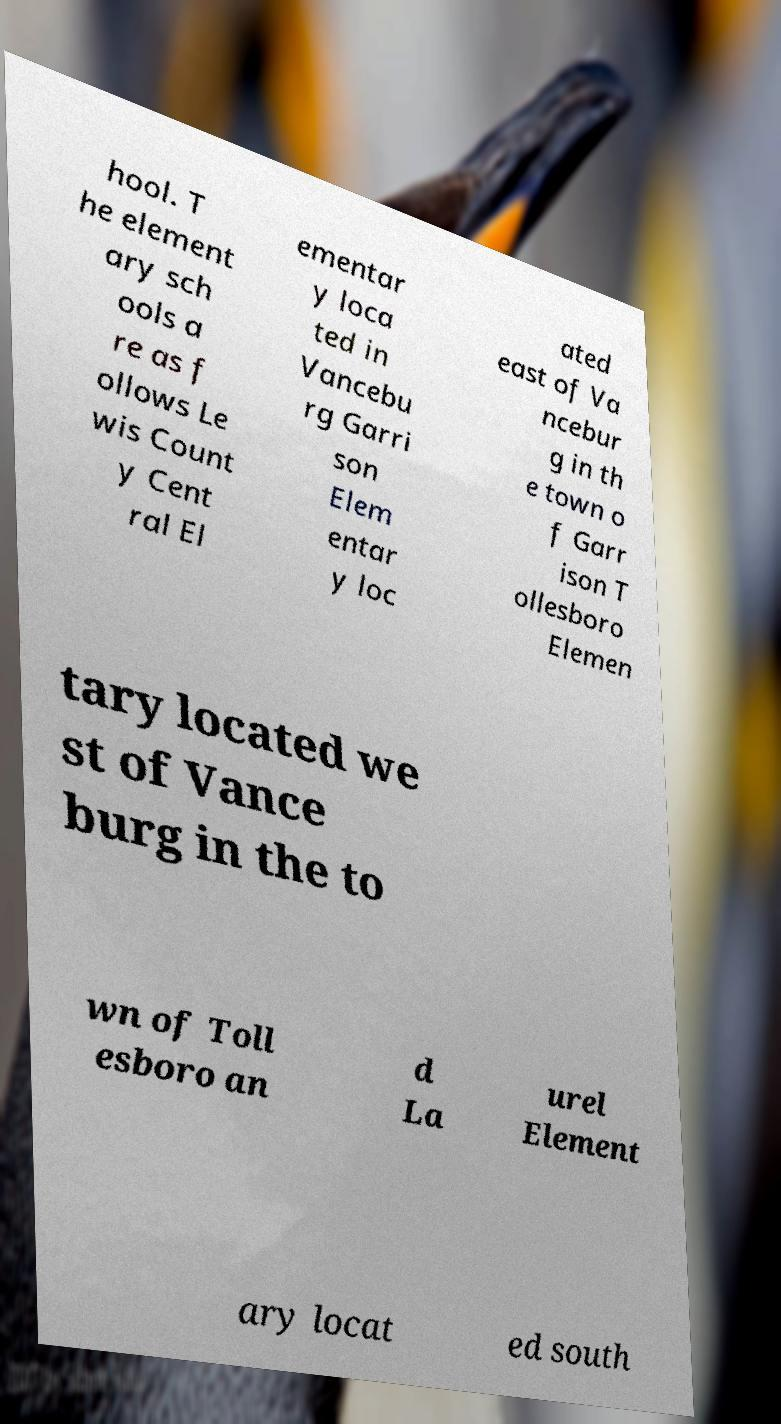Please identify and transcribe the text found in this image. hool. T he element ary sch ools a re as f ollows Le wis Count y Cent ral El ementar y loca ted in Vancebu rg Garri son Elem entar y loc ated east of Va ncebur g in th e town o f Garr ison T ollesboro Elemen tary located we st of Vance burg in the to wn of Toll esboro an d La urel Element ary locat ed south 